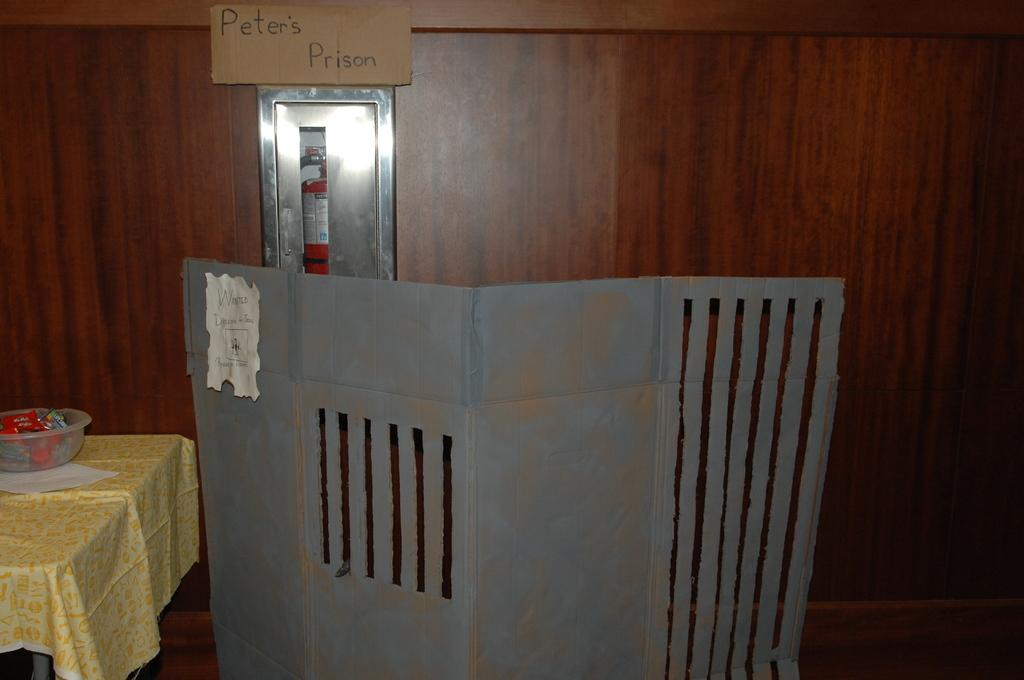<image>
Write a terse but informative summary of the picture. A cardboard mock up of Pete's Prison next to a table with a yellow tablecloth. 